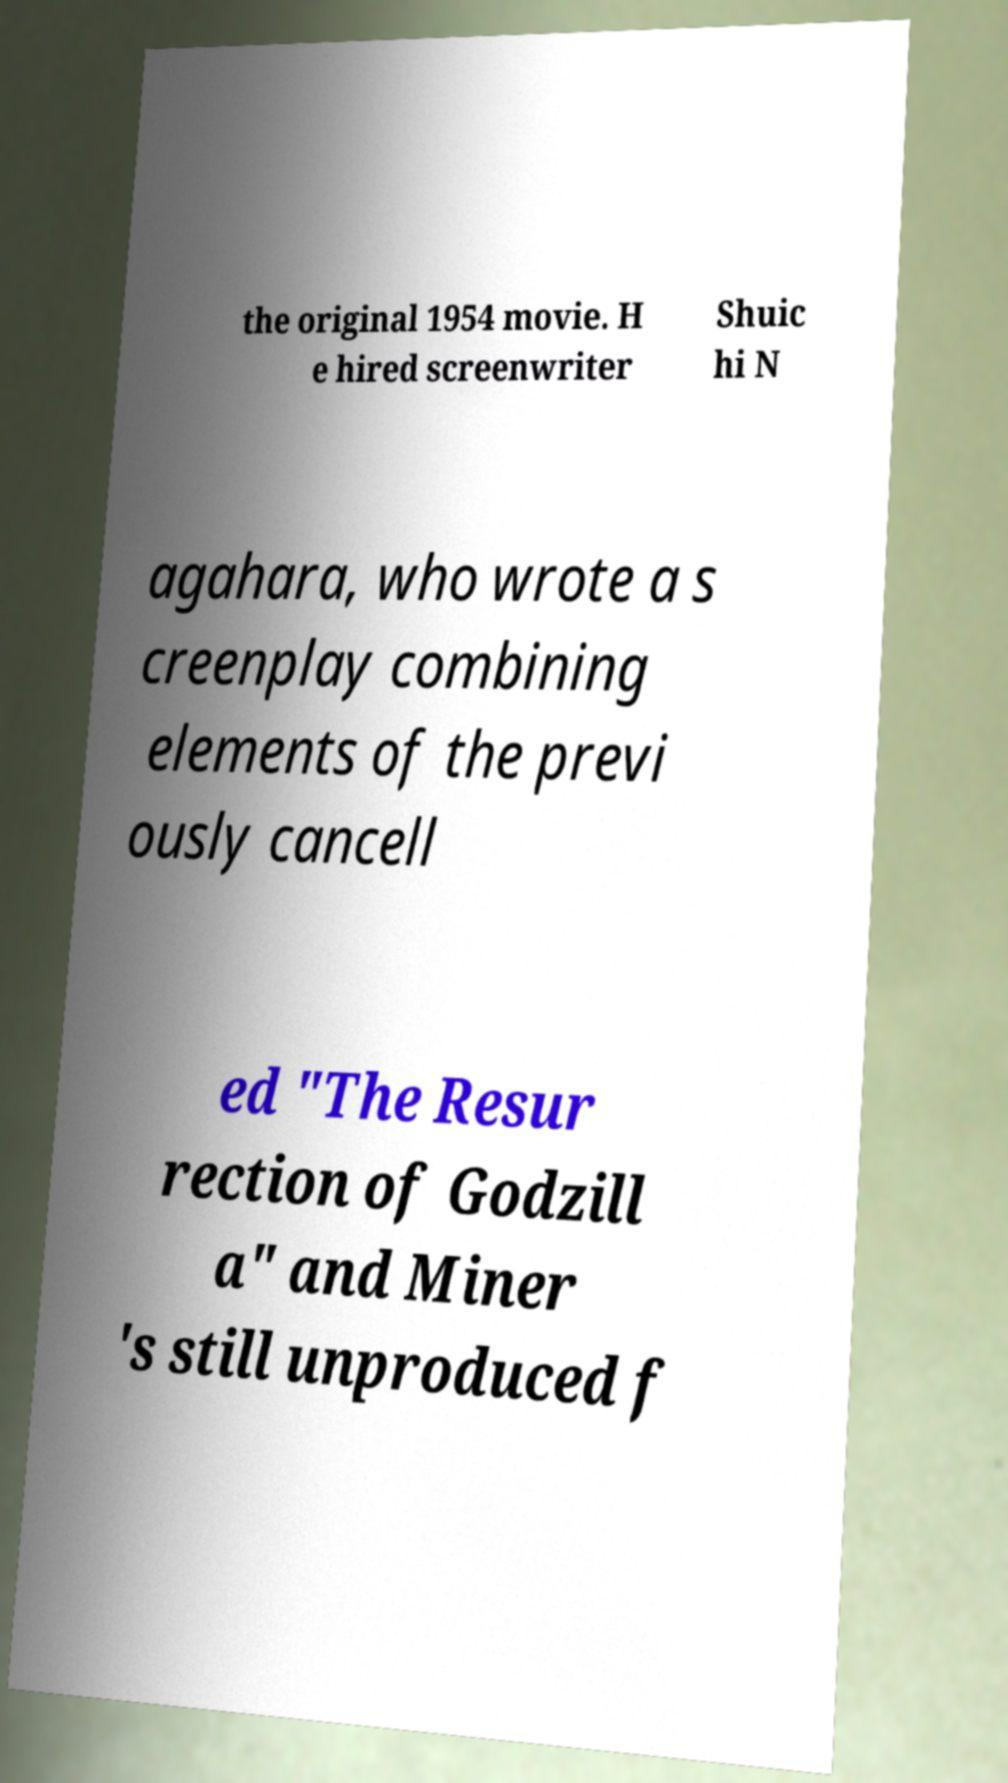Could you extract and type out the text from this image? the original 1954 movie. H e hired screenwriter Shuic hi N agahara, who wrote a s creenplay combining elements of the previ ously cancell ed "The Resur rection of Godzill a" and Miner 's still unproduced f 